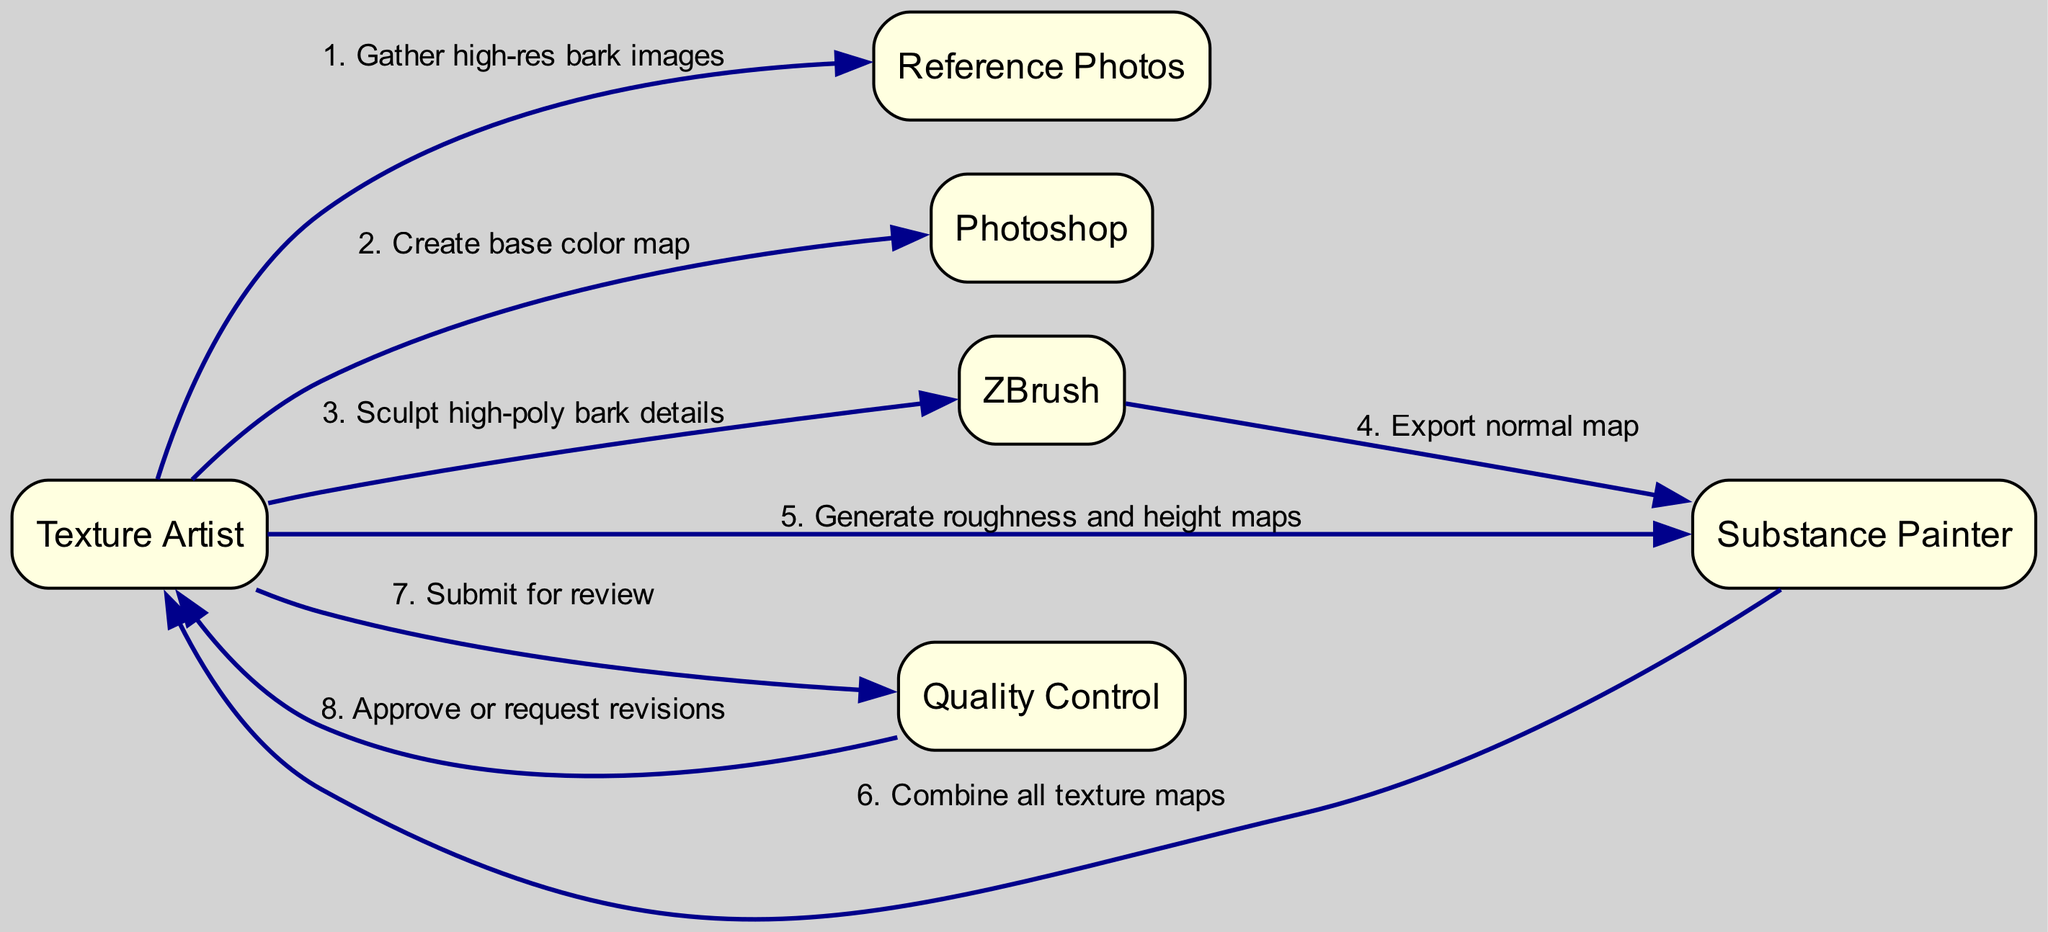What is the first action taken in the workflow? The diagram shows that the first action taken is to "Gather high-res bark images," which is represented by the arrow from the Texture Artist to the Reference Photos.
Answer: Gather high-res bark images How many participants are involved in the texture creation workflow? By counting the individual entries listed in the participants section of the diagram, we see there are six participants: Texture Artist, Reference Photos, Photoshop, ZBrush, Substance Painter, and Quality Control.
Answer: 6 Which software is used to create the base color map? The diagram indicates that the Texture Artist uses Photoshop to "Create base color map," connecting them with an arrow.
Answer: Photoshop What follows after sculpting high-poly bark details in ZBrush? Looking at the sequence, after the action "Sculpt high-poly bark details" in ZBrush, the next action is "Export normal map" to Substance Painter.
Answer: Export normal map What is the final step before submitting for review? The diagram shows that the last action performed before submitting for review is from Substance Painter to the Texture Artist, where they "Combine all texture maps." This combines different texture information together.
Answer: Combine all texture maps How does the Texture Artist generate roughness and height maps? The Texture Artist independently generates roughness and height maps in Substance Painter, as illustrated by the arrow leading to the Substance Painter node labeled "Generate roughness and height maps."
Answer: Generate roughness and height maps What decision follows the submission for review to Quality Control? After the Texture Artist submits for review, Quality Control will then either "Approve or request revisions," illustrating the decision-making process based on the review.
Answer: Approve or request revisions What action occurs after the normal map export? After the action of exporting the normal map from ZBrush, the next step is that the Texture Artist generates roughness and height maps, showing the flow of tasks in the workflow.
Answer: Generate roughness and height maps Which participant is responsible for sculpting high-poly bark details? The diagram clearly indicates that the Texture Artist is responsible for "Sculpt high-poly bark details," marked by the arrow connecting to the ZBrush node.
Answer: Texture Artist 